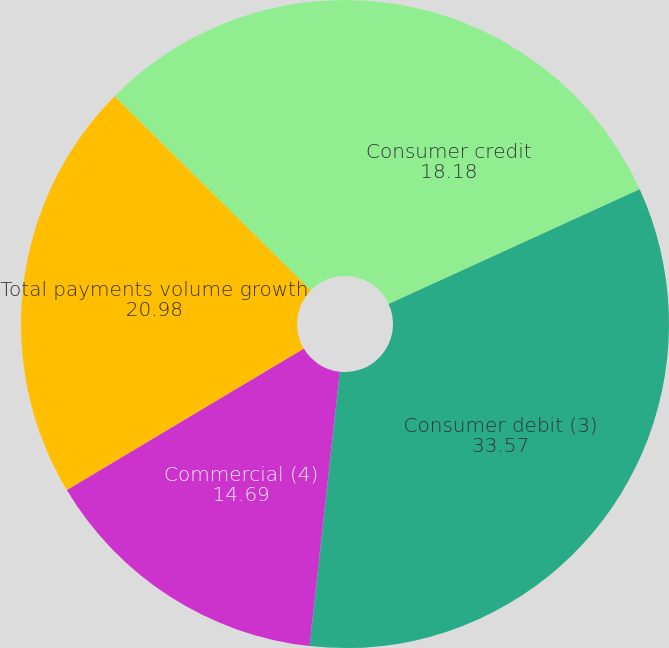Convert chart. <chart><loc_0><loc_0><loc_500><loc_500><pie_chart><fcel>Consumer credit<fcel>Consumer debit (3)<fcel>Commercial (4)<fcel>Total payments volume growth<fcel>Cash volume growth<nl><fcel>18.18%<fcel>33.57%<fcel>14.69%<fcel>20.98%<fcel>12.59%<nl></chart> 